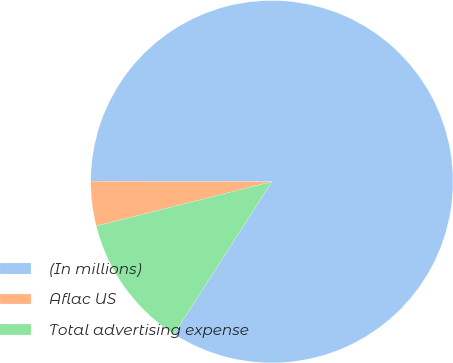Convert chart to OTSL. <chart><loc_0><loc_0><loc_500><loc_500><pie_chart><fcel>(In millions)<fcel>Aflac US<fcel>Total advertising expense<nl><fcel>84.04%<fcel>3.98%<fcel>11.98%<nl></chart> 